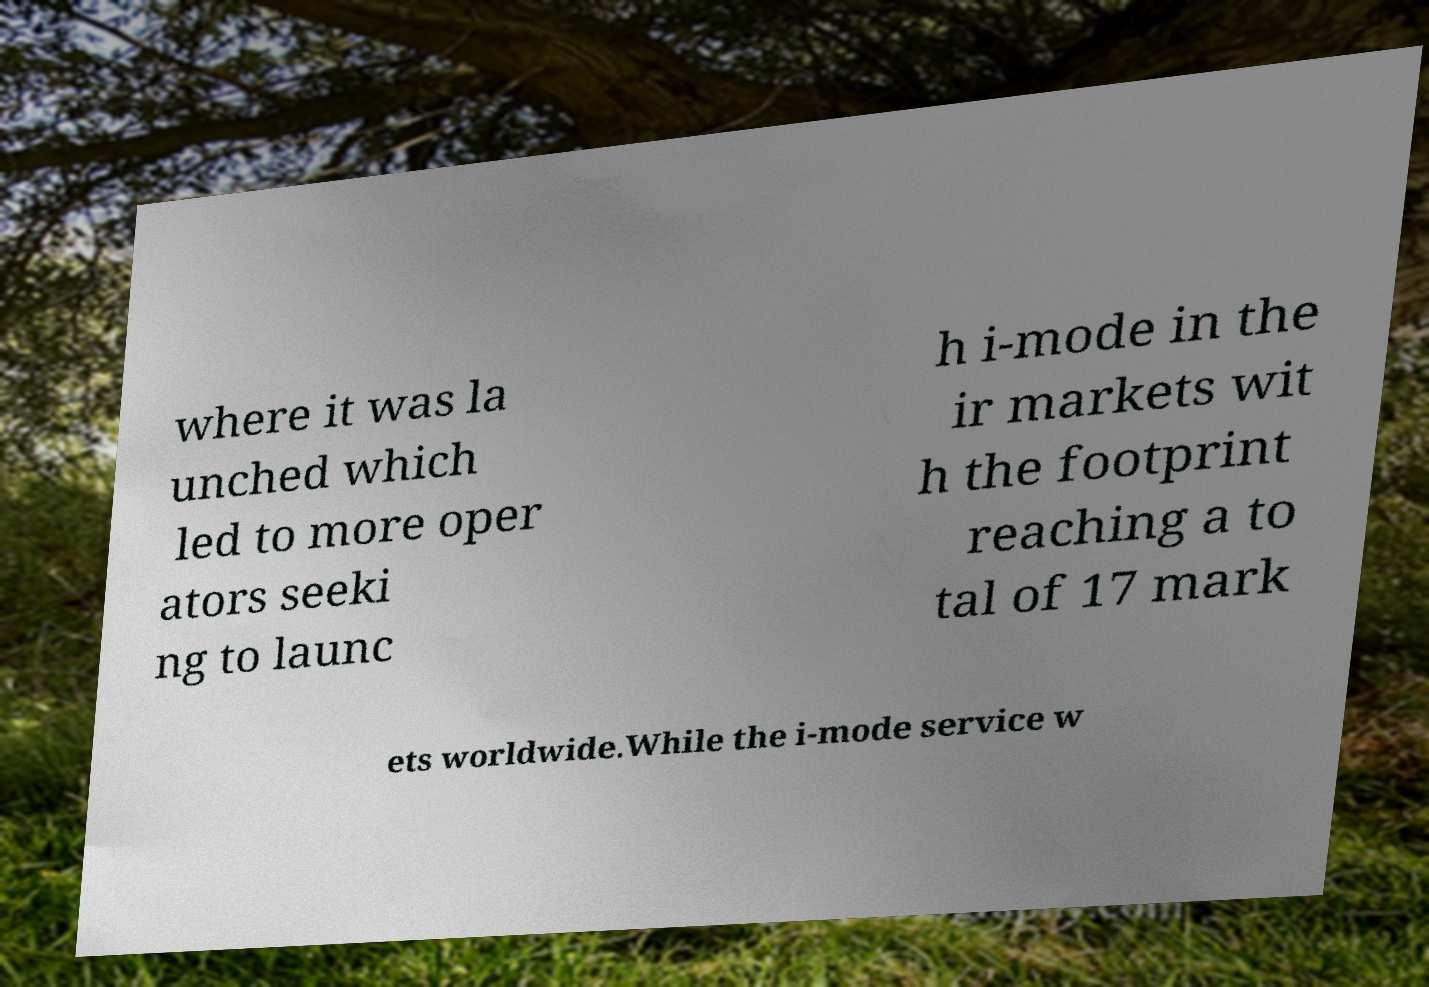I need the written content from this picture converted into text. Can you do that? where it was la unched which led to more oper ators seeki ng to launc h i-mode in the ir markets wit h the footprint reaching a to tal of 17 mark ets worldwide.While the i-mode service w 